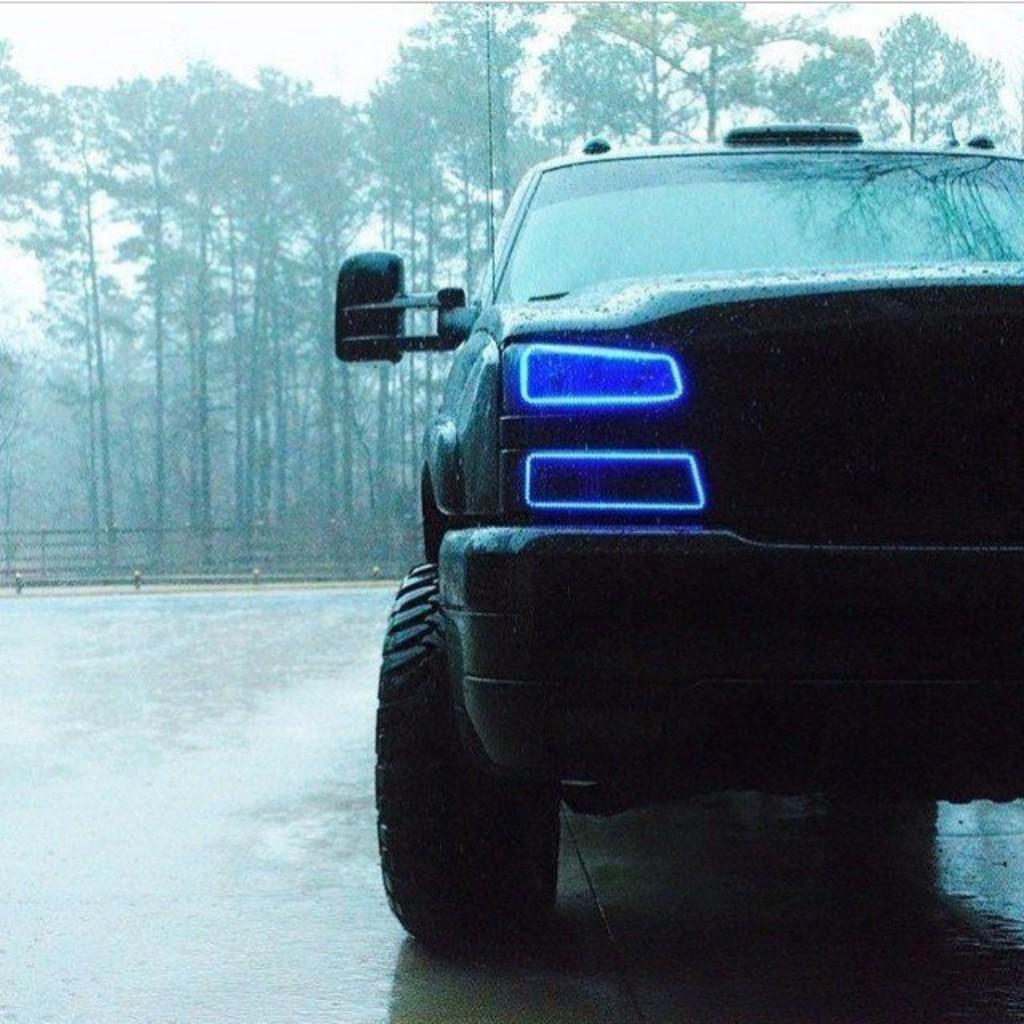Describe this image in one or two sentences. In this image we can see a car on the surface. On the car we can see the light. Behind the car we can see the wooden fencing and a group of trees. At the top we can see the sky. 